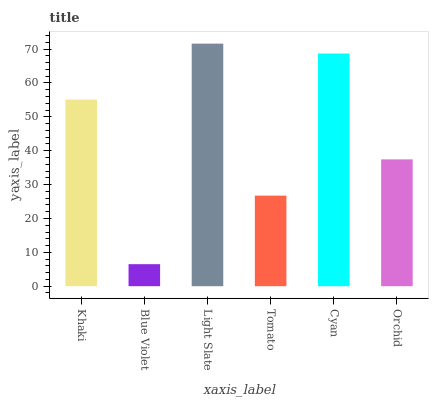Is Blue Violet the minimum?
Answer yes or no. Yes. Is Light Slate the maximum?
Answer yes or no. Yes. Is Light Slate the minimum?
Answer yes or no. No. Is Blue Violet the maximum?
Answer yes or no. No. Is Light Slate greater than Blue Violet?
Answer yes or no. Yes. Is Blue Violet less than Light Slate?
Answer yes or no. Yes. Is Blue Violet greater than Light Slate?
Answer yes or no. No. Is Light Slate less than Blue Violet?
Answer yes or no. No. Is Khaki the high median?
Answer yes or no. Yes. Is Orchid the low median?
Answer yes or no. Yes. Is Tomato the high median?
Answer yes or no. No. Is Cyan the low median?
Answer yes or no. No. 